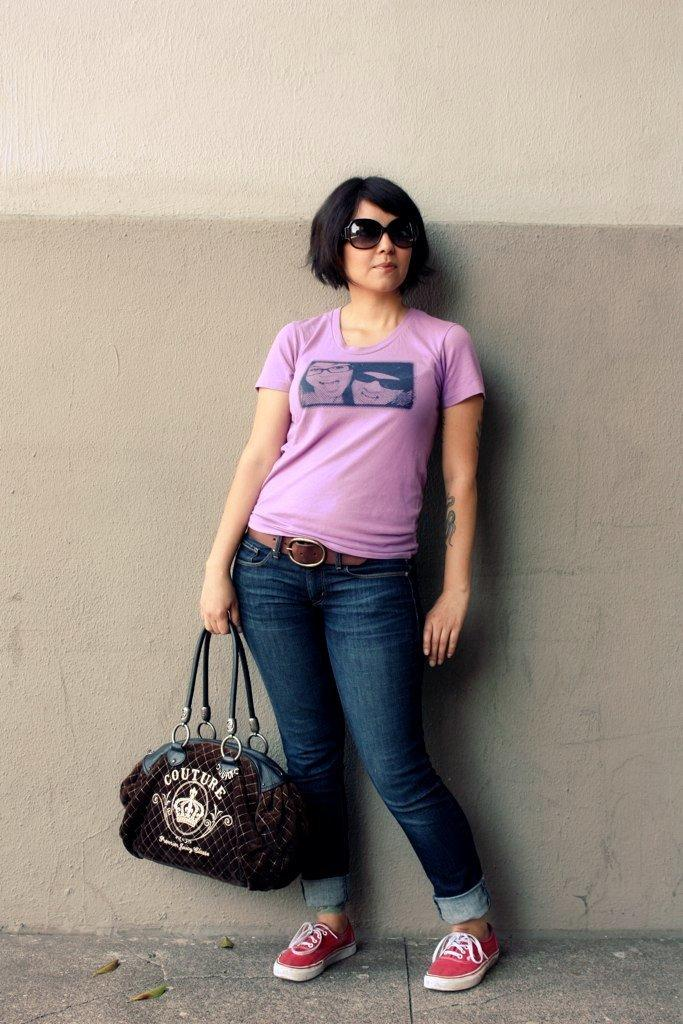Who is the main subject in the image? There is a woman in the image. What is the woman wearing? The woman is wearing a pink t-shirt and blue jeans. What is the woman holding in her hand? The woman is holding a bag in her right hand. What is the woman standing on? The woman is standing on the ground. Is the woman in the image fighting against quicksand? There is no quicksand present in the image, and the woman is standing on solid ground. 